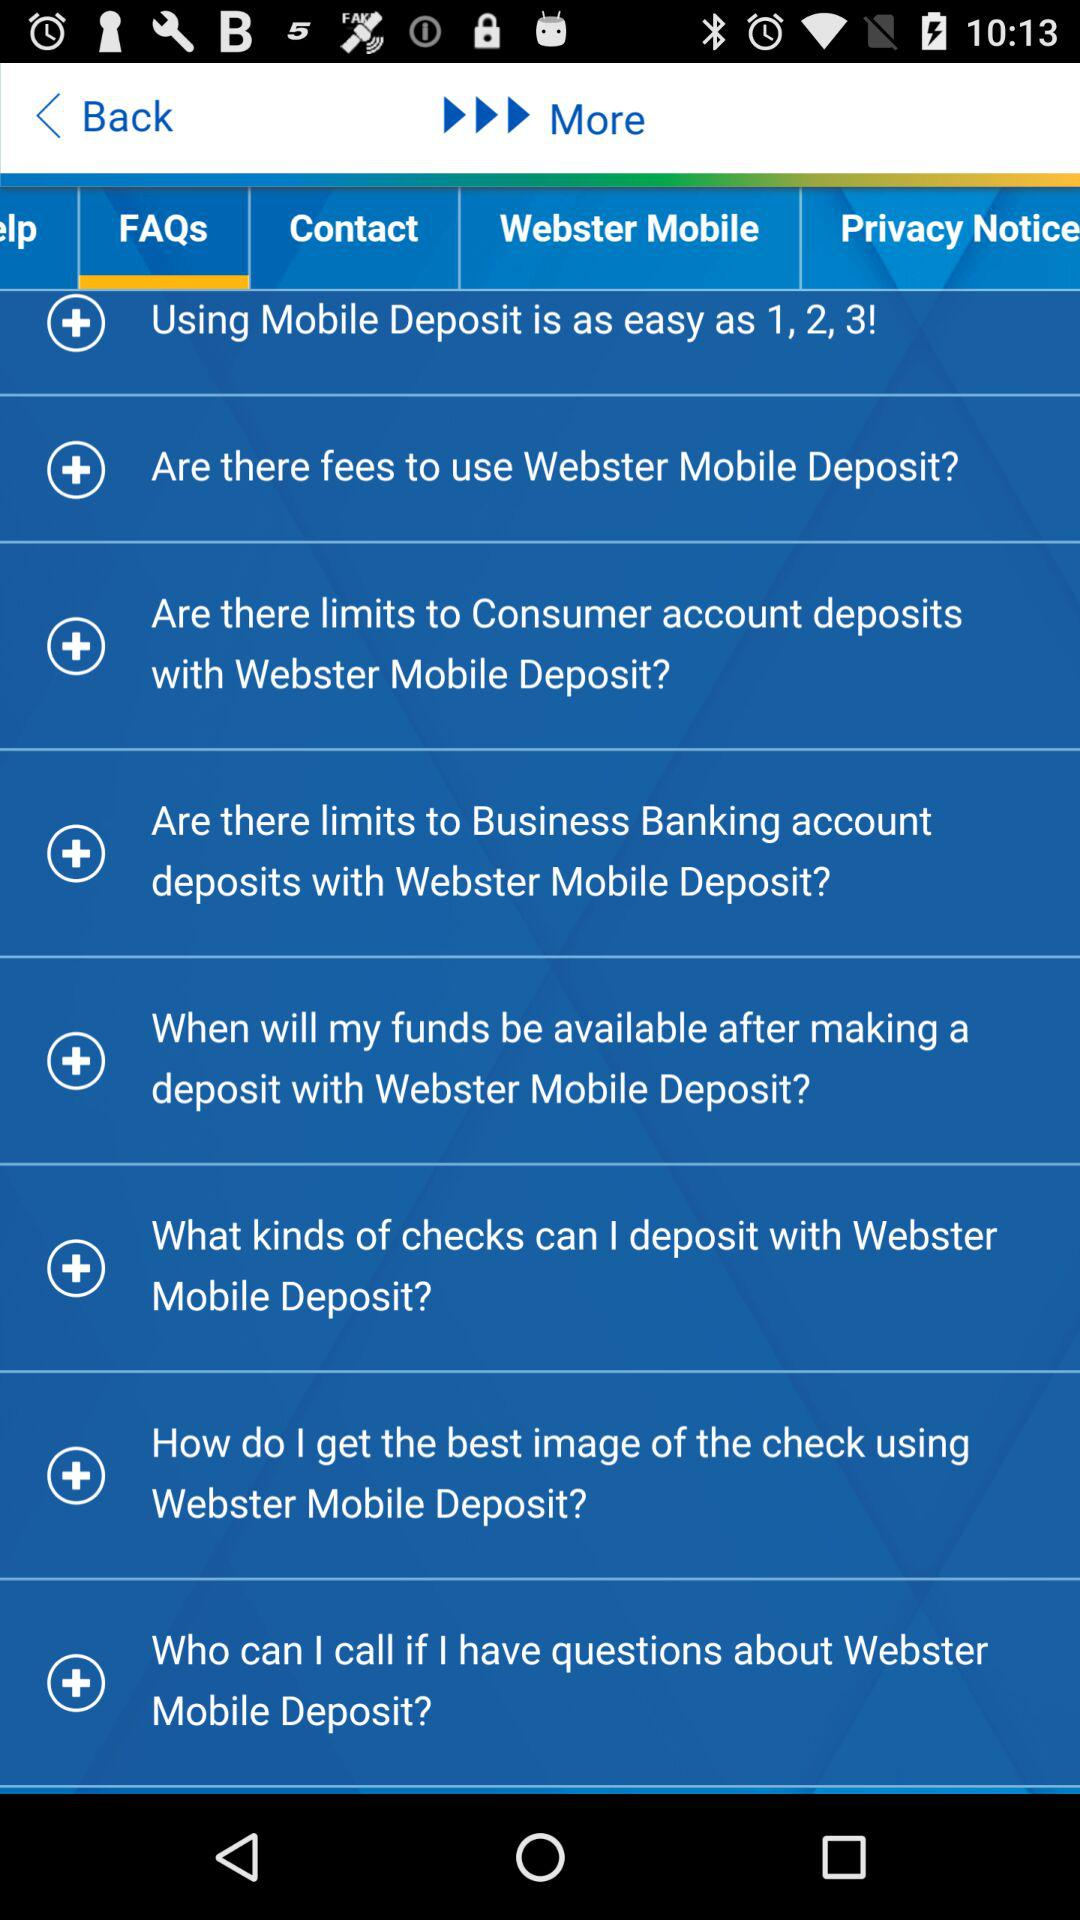How many FAQs are available about Webster Mobile Deposit?
Answer the question using a single word or phrase. 8 